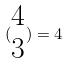<formula> <loc_0><loc_0><loc_500><loc_500>( \begin{matrix} 4 \\ 3 \end{matrix} ) = 4</formula> 